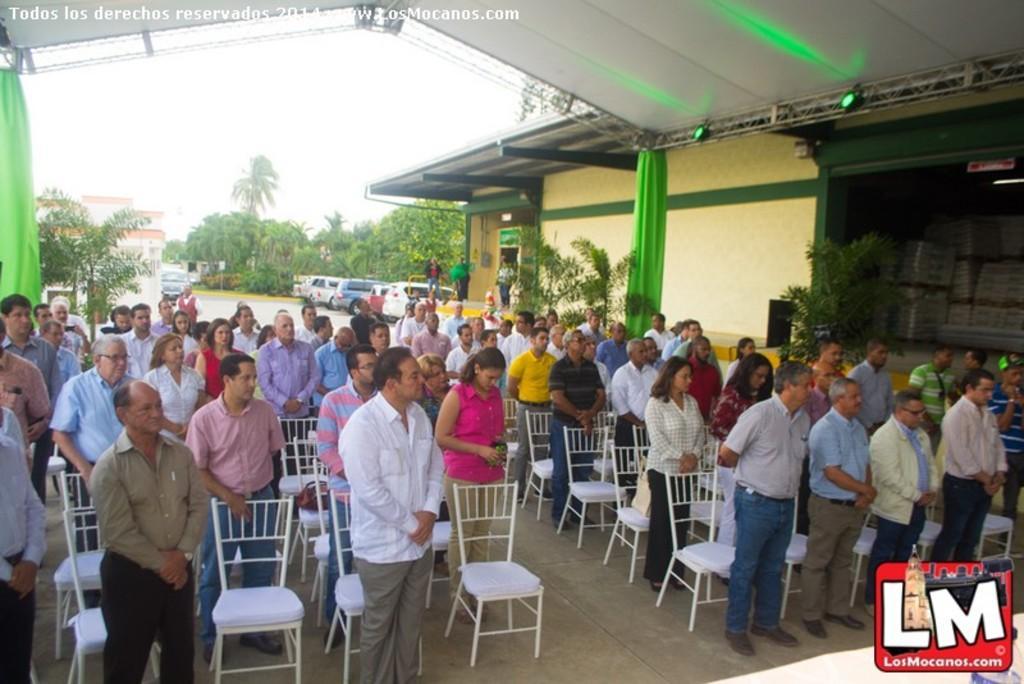Can you describe this image briefly? In this picture there are people in the center of the image those who are standing and there are trees, cars, and buildings in the background area of the image. 